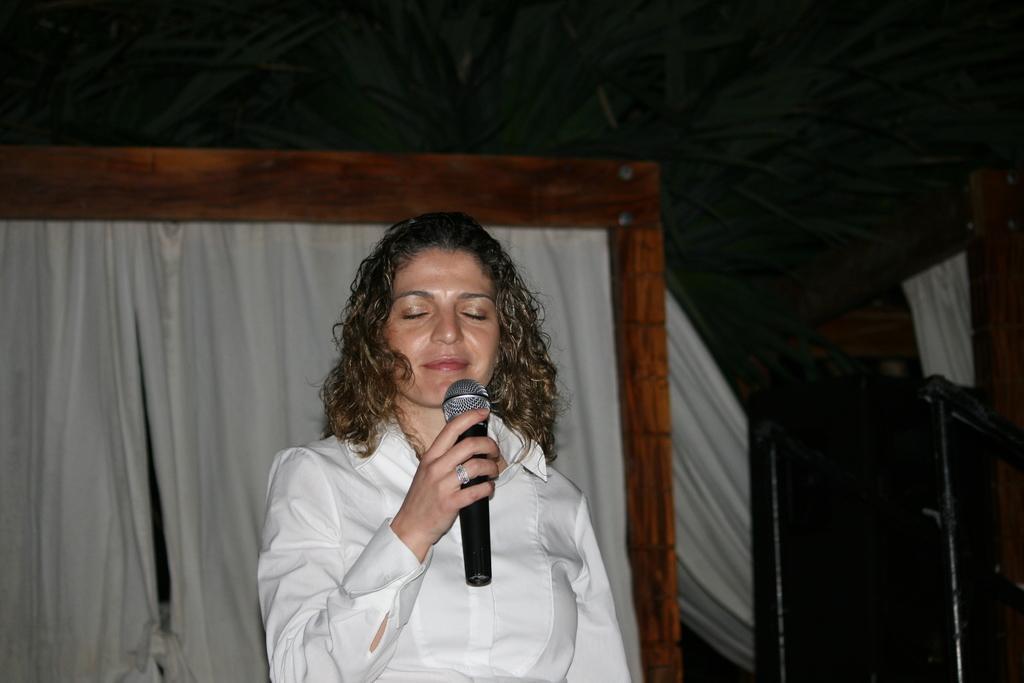Please provide a concise description of this image. In this image we can see one person and holding the microphone, behind we can see the wooden object and curtains, in the bottom right corner we can see an object. 